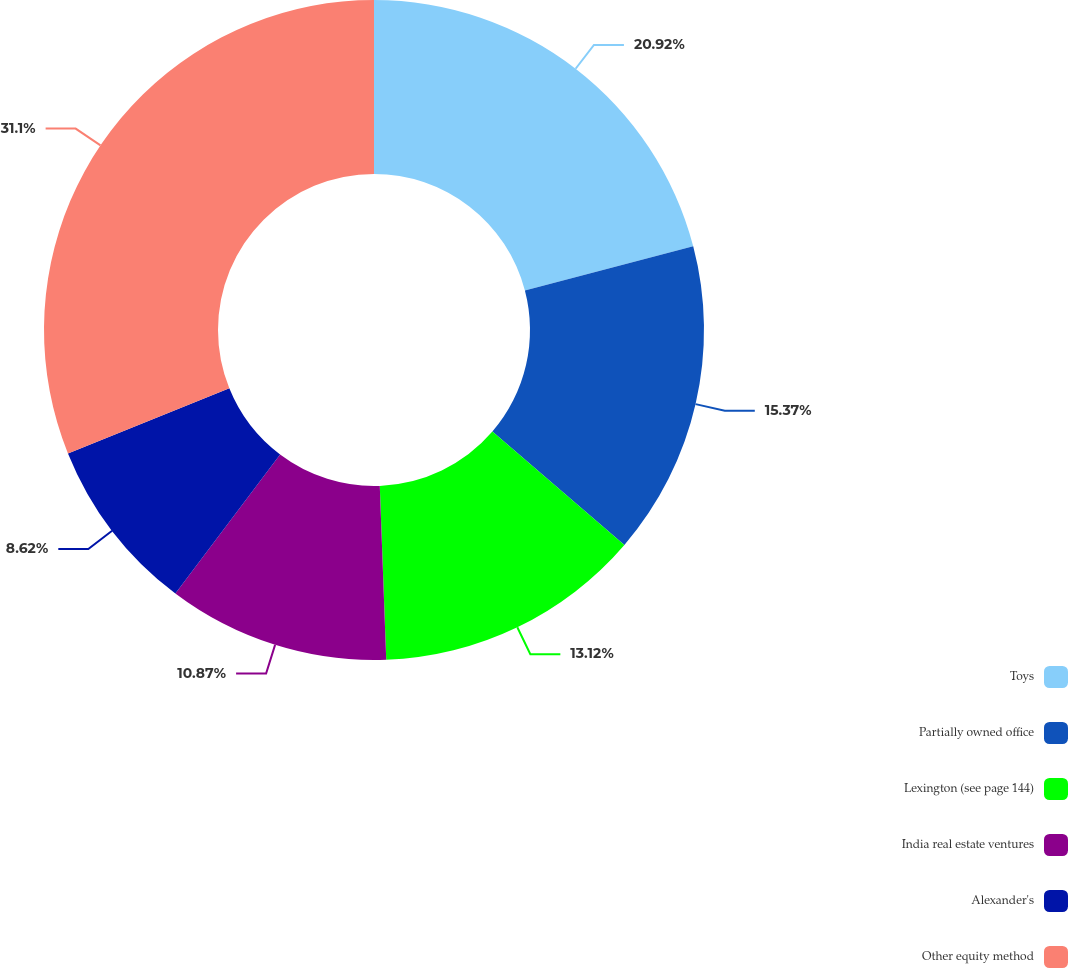Convert chart. <chart><loc_0><loc_0><loc_500><loc_500><pie_chart><fcel>Toys<fcel>Partially owned office<fcel>Lexington (see page 144)<fcel>India real estate ventures<fcel>Alexander's<fcel>Other equity method<nl><fcel>20.92%<fcel>15.37%<fcel>13.12%<fcel>10.87%<fcel>8.62%<fcel>31.1%<nl></chart> 